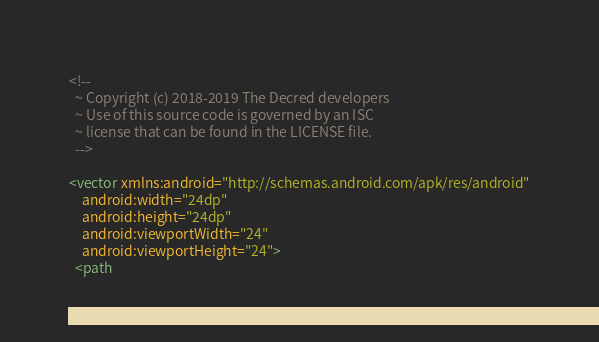Convert code to text. <code><loc_0><loc_0><loc_500><loc_500><_XML_><!--
  ~ Copyright (c) 2018-2019 The Decred developers
  ~ Use of this source code is governed by an ISC
  ~ license that can be found in the LICENSE file.
  -->

<vector xmlns:android="http://schemas.android.com/apk/res/android"
    android:width="24dp"
    android:height="24dp"
    android:viewportWidth="24"
    android:viewportHeight="24">
  <path</code> 